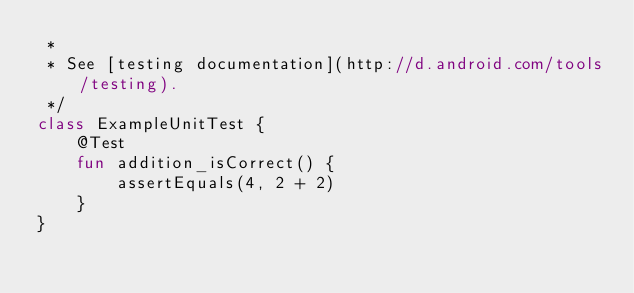<code> <loc_0><loc_0><loc_500><loc_500><_Kotlin_> *
 * See [testing documentation](http://d.android.com/tools/testing).
 */
class ExampleUnitTest {
    @Test
    fun addition_isCorrect() {
        assertEquals(4, 2 + 2)
    }
}
</code> 